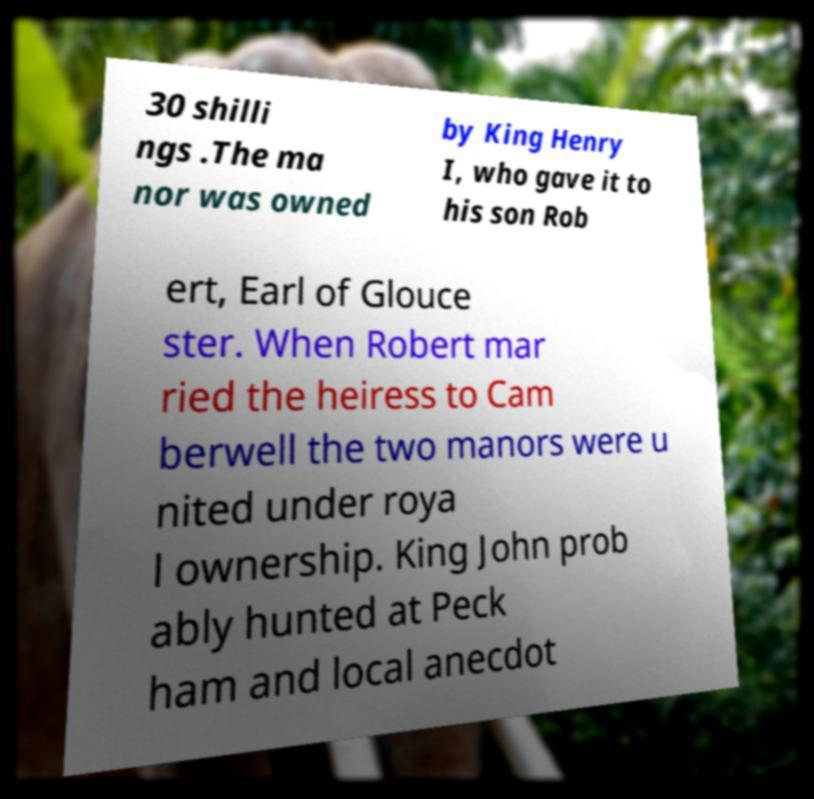Could you extract and type out the text from this image? 30 shilli ngs .The ma nor was owned by King Henry I, who gave it to his son Rob ert, Earl of Glouce ster. When Robert mar ried the heiress to Cam berwell the two manors were u nited under roya l ownership. King John prob ably hunted at Peck ham and local anecdot 